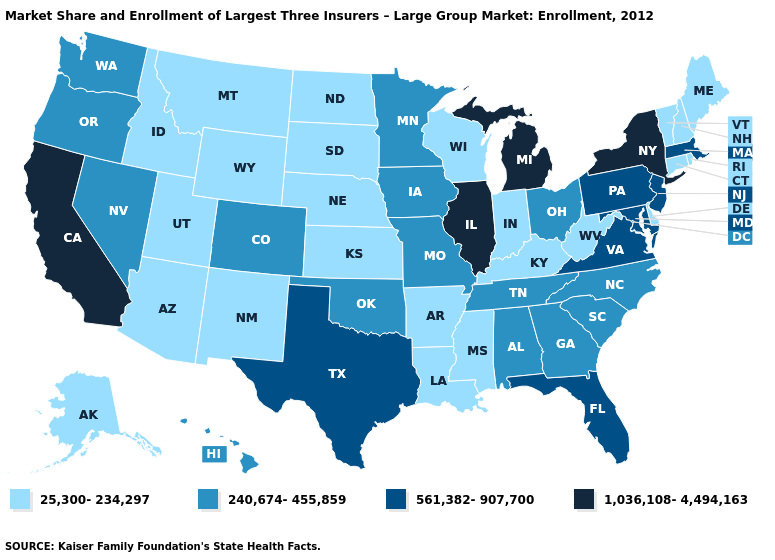What is the highest value in states that border South Carolina?
Answer briefly. 240,674-455,859. What is the value of Kansas?
Short answer required. 25,300-234,297. Among the states that border Connecticut , does Massachusetts have the lowest value?
Keep it brief. No. What is the value of Michigan?
Answer briefly. 1,036,108-4,494,163. What is the highest value in the USA?
Write a very short answer. 1,036,108-4,494,163. Among the states that border Wyoming , which have the lowest value?
Give a very brief answer. Idaho, Montana, Nebraska, South Dakota, Utah. Which states have the highest value in the USA?
Write a very short answer. California, Illinois, Michigan, New York. Name the states that have a value in the range 1,036,108-4,494,163?
Concise answer only. California, Illinois, Michigan, New York. Which states have the highest value in the USA?
Concise answer only. California, Illinois, Michigan, New York. What is the highest value in the USA?
Write a very short answer. 1,036,108-4,494,163. Which states have the lowest value in the Northeast?
Concise answer only. Connecticut, Maine, New Hampshire, Rhode Island, Vermont. What is the value of Montana?
Answer briefly. 25,300-234,297. What is the value of New Hampshire?
Give a very brief answer. 25,300-234,297. Among the states that border Connecticut , does Rhode Island have the lowest value?
Answer briefly. Yes. Which states have the lowest value in the Northeast?
Be succinct. Connecticut, Maine, New Hampshire, Rhode Island, Vermont. 